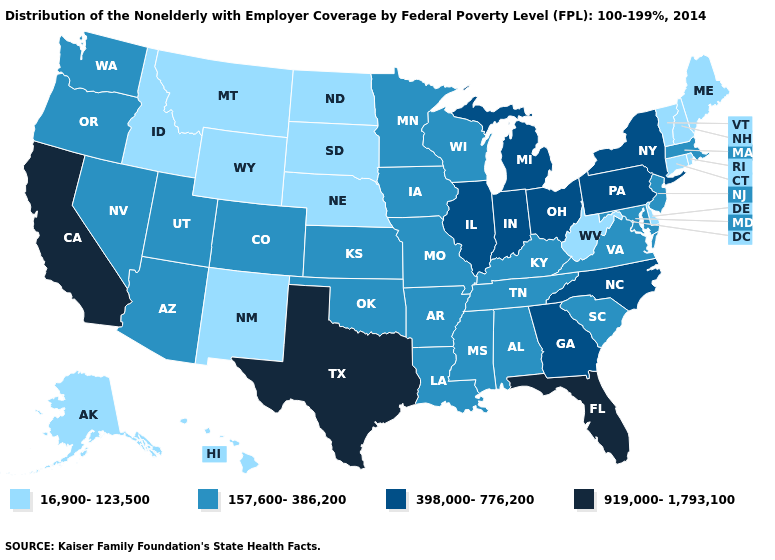What is the value of Arizona?
Short answer required. 157,600-386,200. What is the highest value in states that border Oklahoma?
Short answer required. 919,000-1,793,100. What is the value of Kansas?
Concise answer only. 157,600-386,200. What is the lowest value in states that border Connecticut?
Concise answer only. 16,900-123,500. What is the lowest value in the Northeast?
Answer briefly. 16,900-123,500. Which states have the highest value in the USA?
Give a very brief answer. California, Florida, Texas. Among the states that border South Carolina , which have the highest value?
Short answer required. Georgia, North Carolina. What is the value of Wyoming?
Short answer required. 16,900-123,500. Among the states that border Arkansas , which have the lowest value?
Quick response, please. Louisiana, Mississippi, Missouri, Oklahoma, Tennessee. Does Minnesota have the highest value in the USA?
Write a very short answer. No. What is the highest value in the South ?
Quick response, please. 919,000-1,793,100. Does the first symbol in the legend represent the smallest category?
Be succinct. Yes. Does Vermont have a higher value than Oklahoma?
Short answer required. No. Name the states that have a value in the range 398,000-776,200?
Quick response, please. Georgia, Illinois, Indiana, Michigan, New York, North Carolina, Ohio, Pennsylvania. Does New Hampshire have the lowest value in the USA?
Concise answer only. Yes. 